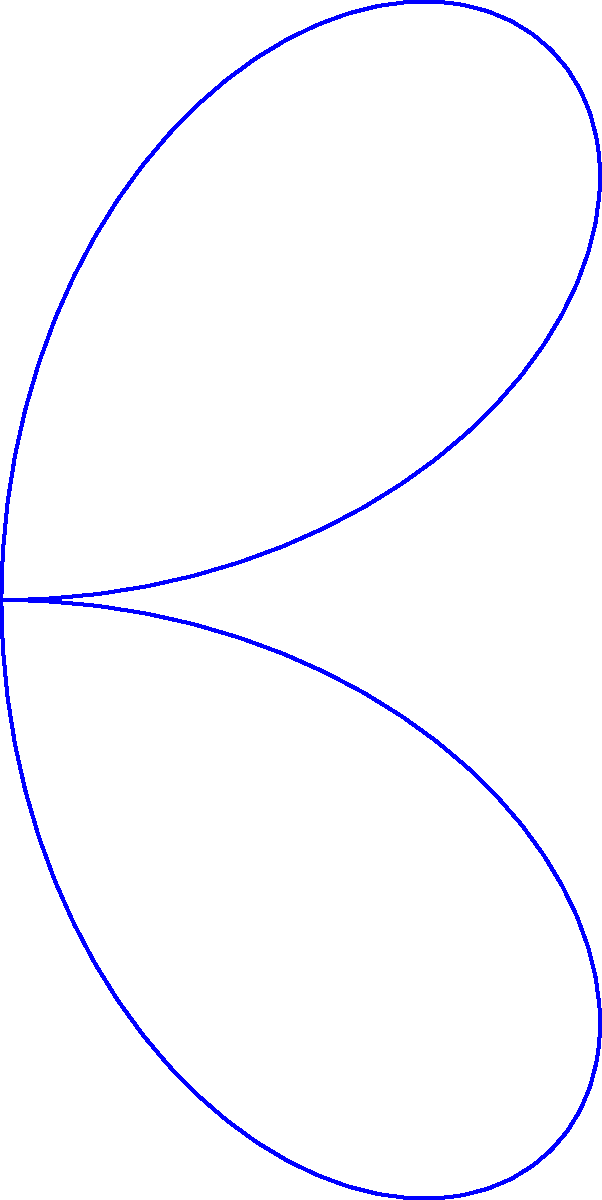In a new game mode, projectiles follow a rose curve trajectory described by the polar equation $r = 50 \sin(2\theta)$. The blue curve represents the initial trajectory, and the red dashed curve shows the return path. What is the maximum range of the projectile in game units, and at what polar angle $\theta$ (in radians) does this occur? To solve this problem, we need to follow these steps:

1) The maximum range occurs at the maximum value of $r$ in the equation $r = 50 \sin(2\theta)$.

2) The maximum value of sine is 1, which occurs when its argument is $\frac{\pi}{2}$ (or odd multiples of it).

3) So, we need to solve: $2\theta = \frac{\pi}{2}$ (for the first maximum)

4) Solving for $\theta$:
   $\theta = \frac{\pi}{4}$ radians

5) To find the maximum range, we substitute this value back into the original equation:
   $r_{max} = 50 \sin(2 \cdot \frac{\pi}{4}) = 50 \sin(\frac{\pi}{2}) = 50$

6) Therefore, the maximum range is 50 game units, occurring at $\theta = \frac{\pi}{4}$ radians.

Note: Due to the symmetry of the sine function, this maximum also occurs at $\theta = \frac{3\pi}{4}$, $\frac{5\pi}{4}$, and $\frac{7\pi}{4}$ radians, but we typically consider the first occurrence.
Answer: 50 units at $\frac{\pi}{4}$ radians 